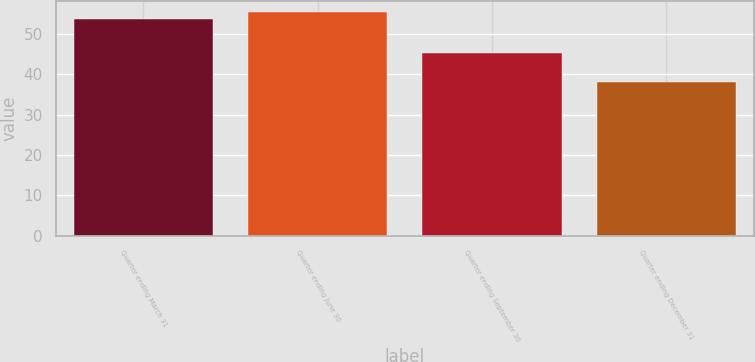Convert chart to OTSL. <chart><loc_0><loc_0><loc_500><loc_500><bar_chart><fcel>Quarter ending March 31<fcel>Quarter ending June 30<fcel>Quarter ending September 30<fcel>Quarter ending December 31<nl><fcel>53.66<fcel>55.37<fcel>45.3<fcel>37.97<nl></chart> 